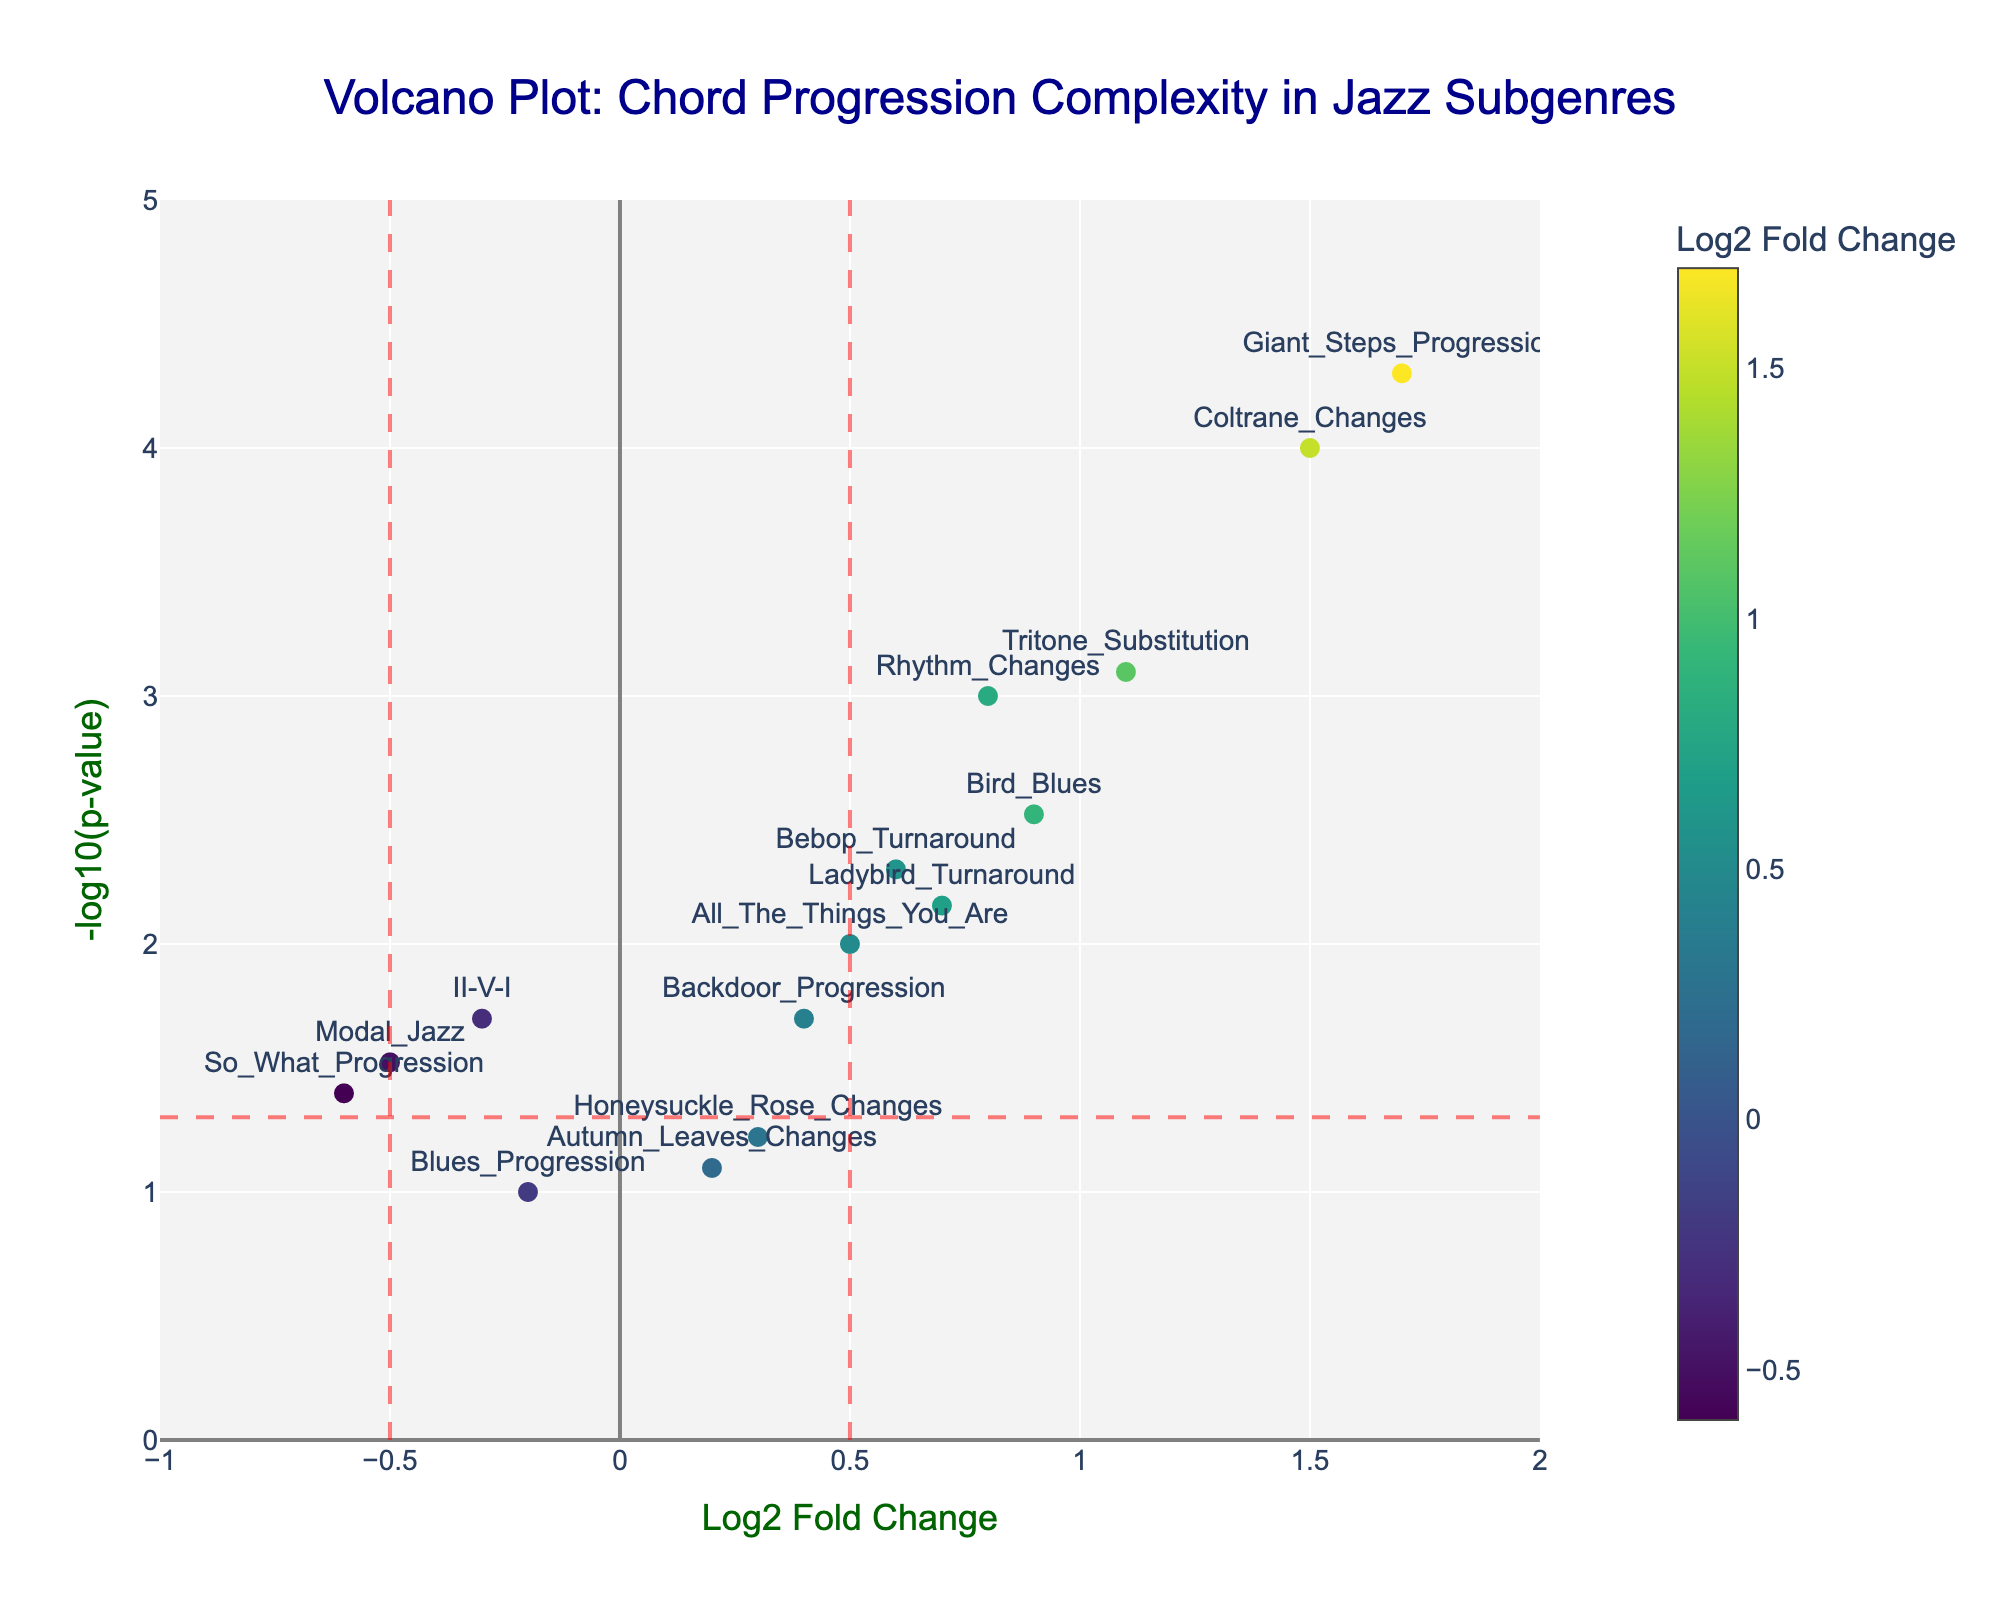How many chord progressions are analyzed in this Volcano Plot? By counting the markers on the plot, we observe that each marker represents one chord progression. Therefore, the number of chord progressions analyzed corresponds to the number of markers.
Answer: 15 Which chord progression has the highest statistical significance? To find the chord progression with the highest statistical significance, look for the point with the highest -log10(p-value). The "Giant_Steps_Progression" has the highest -log10(p-value) on the plot.
Answer: Giant Steps Progression Which chord progressions show a fold change greater than 1? Fold change greater than 1 means the x-coordinate (Log2 Fold Change) is greater than 1. The chord progressions "Coltrane_Changes", "Tritone_Substitution", and "Giant_Steps_Progression" fall into this category.
Answer: Coltrane Changes, Tritone Substitution, Giant Steps Progression What fold change value is considered a threshold in the plot? The vertical red lines indicate that the threshold fold change values are at x = -0.5 and x = 0.5.
Answer: -0.5 and 0.5 Which chord progression is closest to the threshold of statistical significance (p = 0.05)? The threshold for statistical significance is indicated by the red horizontal line corresponding to -log10(0.05). "Backdoor_Progression" appears very close to this line.
Answer: Backdoor Progression Is "Rhythm_Changes" statistically significant, and what is its fold change? "Rhythm_Changes" is above the horizontal red line (p<0.05), indicating it is statistically significant. Its fold change is about 0.8.
Answer: Yes, 0.8 Which chord progressions have a fold change less than -0.5 and are statistically significant? A fold change less than -0.5 means x < -0.5, and statistical significance indicates a position above the red horizontal line. "So_What_Progression" fits this criterion.
Answer: So What Progression Compare the fold change values of "Bird_Blues" and "Bebop_Turnaround". Which one is higher? By checking the Log2 Fold Change values, "Bird_Blues" has a fold change of 0.9, whereas "Bebop_Turnaround" has a fold change of 0.6. Therefore, "Bird_Blues" has a higher fold change.
Answer: Bird Blues Which chord progression has the lowest fold change and is statistically significant? To find the lowest fold change, locate the point with the lowest x-coordinate value, which is "-0.6" for "So_What_Progression". It is above the horizontal significance line.
Answer: So What Progression 